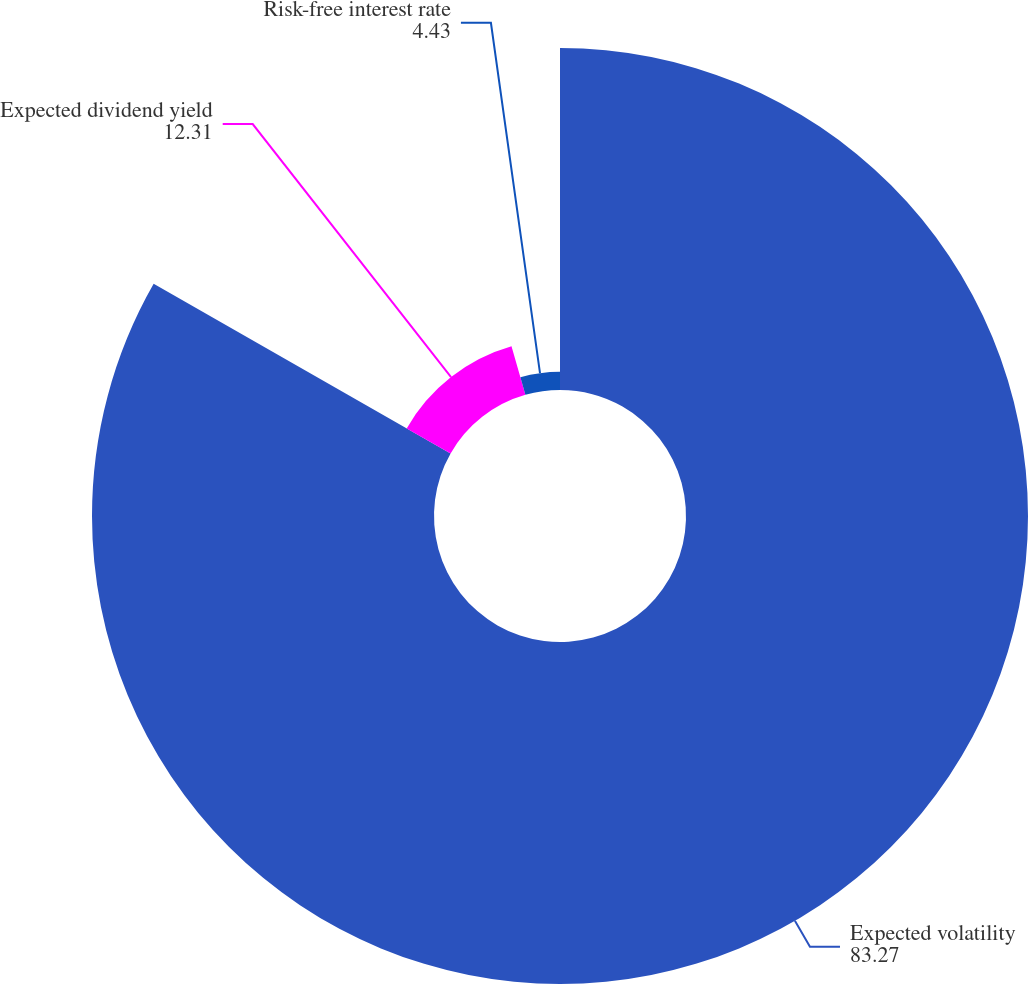<chart> <loc_0><loc_0><loc_500><loc_500><pie_chart><fcel>Expected volatility<fcel>Expected dividend yield<fcel>Risk-free interest rate<nl><fcel>83.27%<fcel>12.31%<fcel>4.43%<nl></chart> 